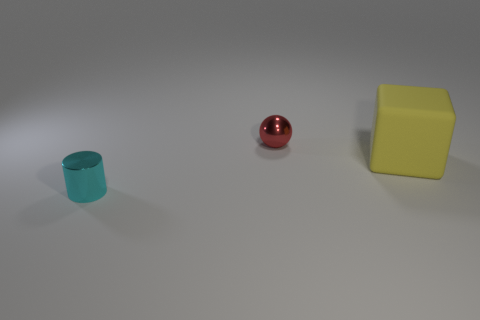Is the number of cyan metal objects to the left of the big rubber cube greater than the number of yellow rubber things?
Your response must be concise. No. What color is the thing that is left of the tiny red shiny ball?
Ensure brevity in your answer.  Cyan. How many rubber objects are gray blocks or small cyan cylinders?
Keep it short and to the point. 0. Are there any tiny balls that are in front of the metal thing that is to the left of the metallic thing behind the big thing?
Provide a short and direct response. No. How many spheres are to the right of the cyan cylinder?
Your response must be concise. 1. What number of tiny things are either purple metal balls or cyan shiny cylinders?
Ensure brevity in your answer.  1. There is a object behind the yellow object; what is its shape?
Your answer should be compact. Sphere. Is there a thing that has the same color as the big rubber block?
Offer a very short reply. No. There is a cyan thing that is to the left of the red shiny ball; is it the same size as the shiny object behind the tiny cyan metallic object?
Keep it short and to the point. Yes. Are there more yellow objects in front of the large cube than small cyan cylinders behind the small shiny ball?
Ensure brevity in your answer.  No. 